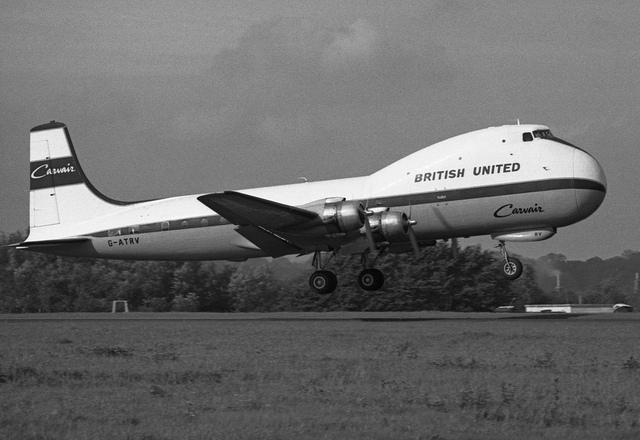What does it say on the plane?
Short answer required. British united. What word is on the plane's tail?
Concise answer only. Caviar. What is the paint color of the world British United?
Keep it brief. Black. How many propellers does the plane have?
Keep it brief. 4. What is written on the side of the plane?
Short answer required. British united. Is the plane airborne?
Quick response, please. Yes. Where does it say D-ATV?
Concise answer only. Bottom of plane. 